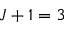<formula> <loc_0><loc_0><loc_500><loc_500>J + 1 = 3</formula> 